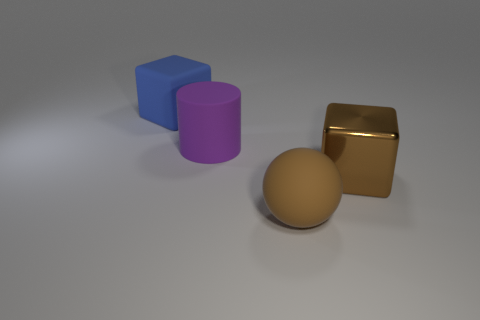What number of large objects are either gray shiny objects or blue things?
Provide a short and direct response. 1. There is another big blue object that is the same shape as the shiny object; what is its material?
Your response must be concise. Rubber. Is there any other thing that is the same material as the big sphere?
Provide a short and direct response. Yes. The big matte cylinder is what color?
Give a very brief answer. Purple. Is the big rubber cylinder the same color as the big metallic object?
Your answer should be very brief. No. How many brown cubes are behind the object that is to the left of the big purple matte cylinder?
Give a very brief answer. 0. How big is the object that is in front of the blue rubber cube and left of the big brown ball?
Give a very brief answer. Large. What is the material of the block that is in front of the blue thing?
Ensure brevity in your answer.  Metal. Are there any large brown matte things of the same shape as the purple object?
Make the answer very short. No. What number of other large brown matte objects have the same shape as the brown rubber object?
Your answer should be very brief. 0. 